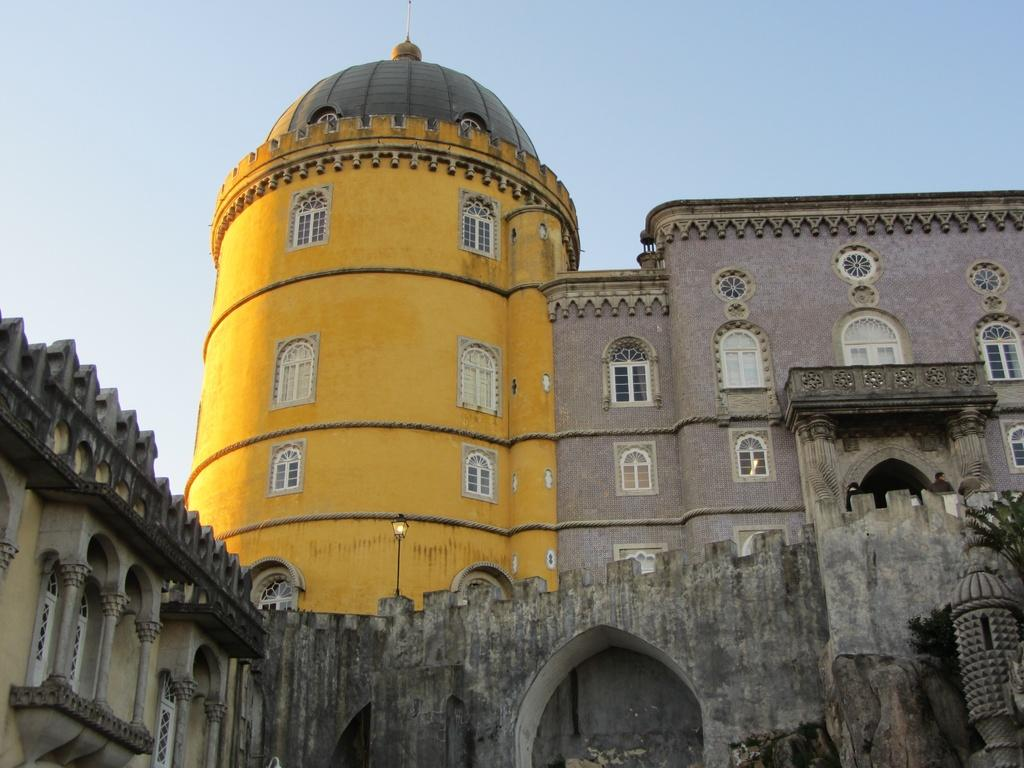What type of structures are present in the image? There are buildings in the image. What colors can be seen on the buildings? The buildings have yellow, cream, and light brown colors. What architectural features are visible on the buildings? There are windows visible on the buildings. What is the color of the sky in the background? The sky in the background has a white and blue color. Can you see a match being lit in the image? There is no match present in the image. What type of mint is growing on the buildings in the image? There is no mint growing on the buildings in the image. 